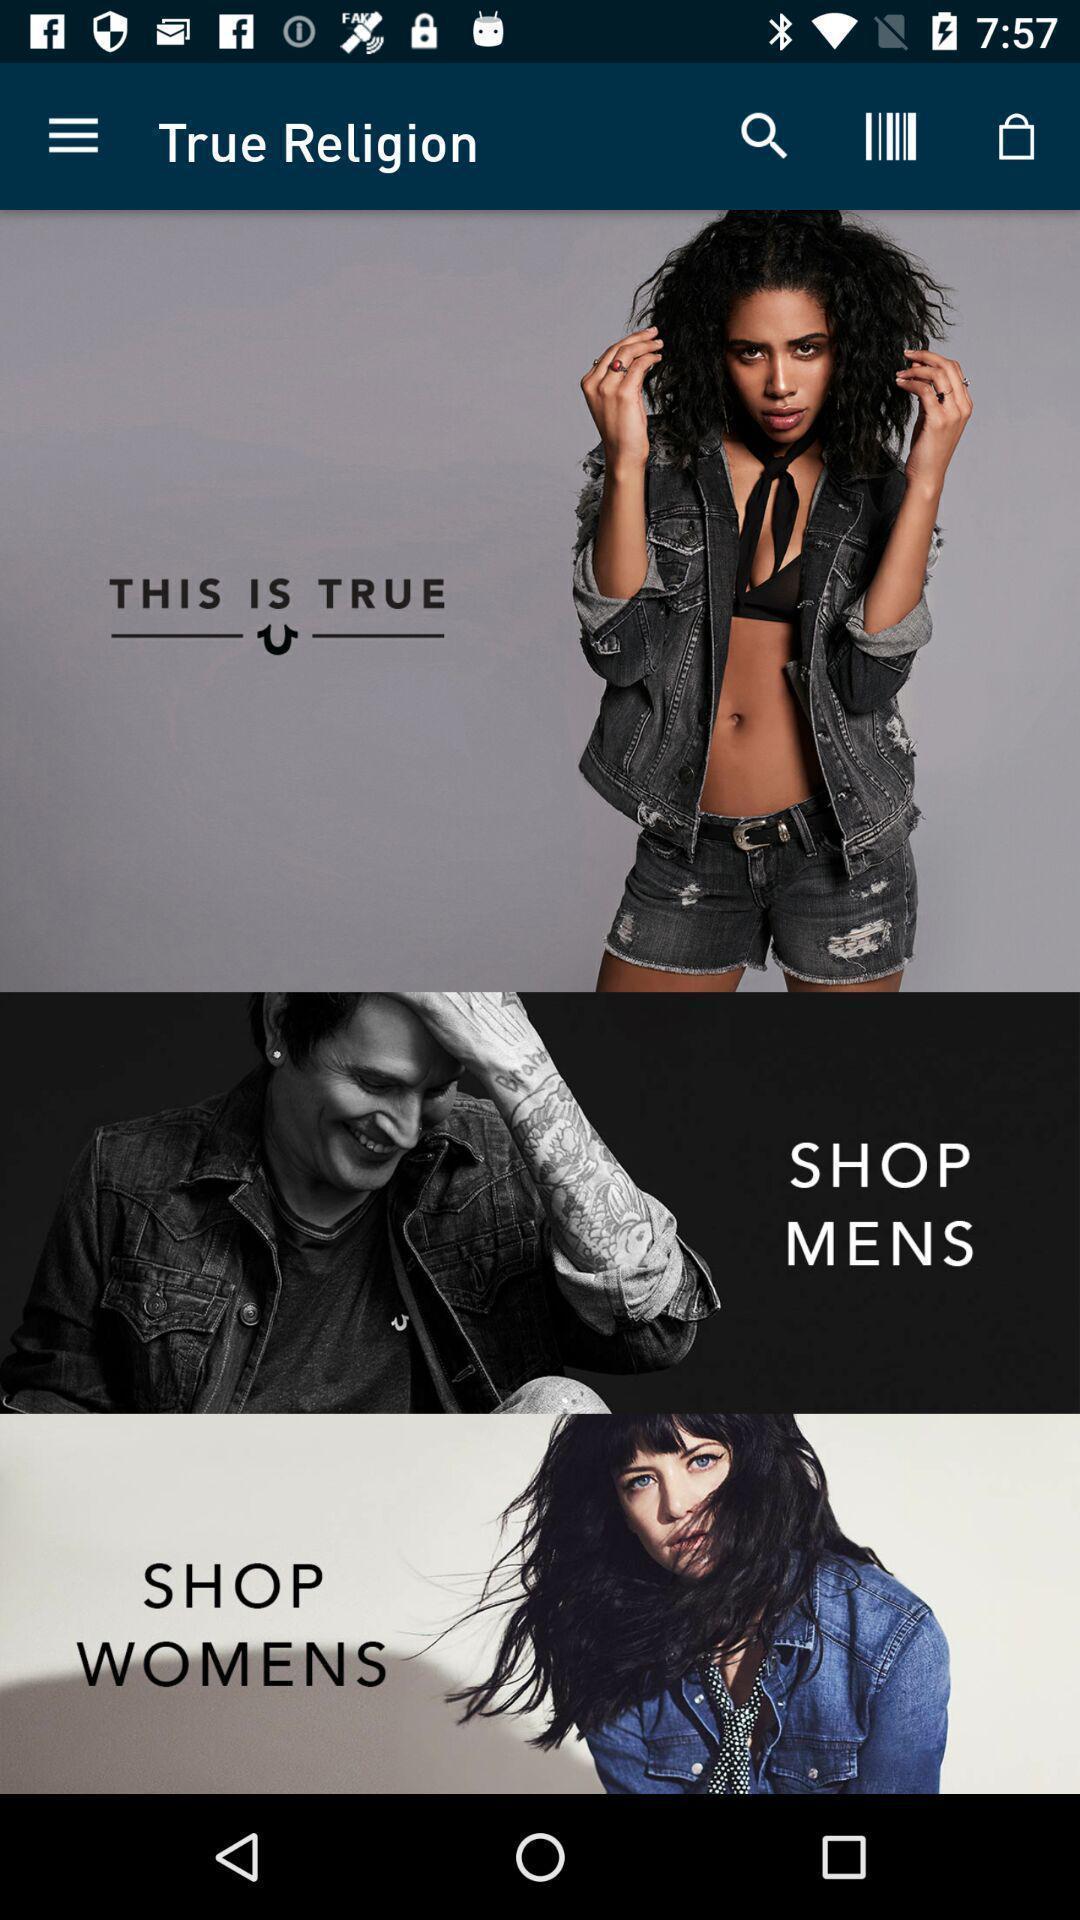Tell me what you see in this picture. Page showing multiple suggestions. 